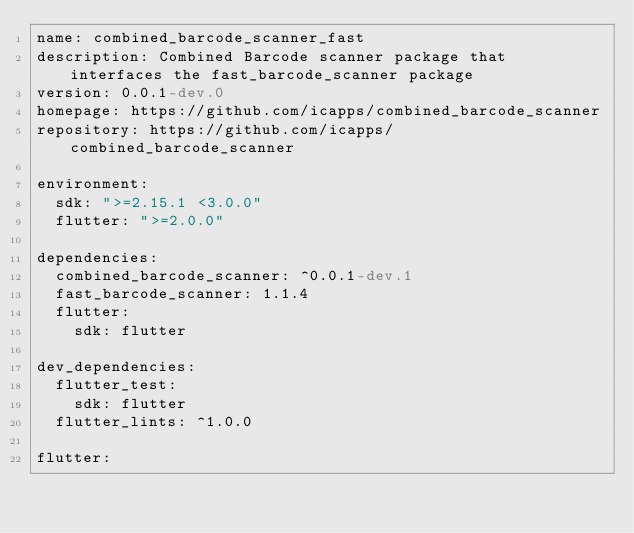Convert code to text. <code><loc_0><loc_0><loc_500><loc_500><_YAML_>name: combined_barcode_scanner_fast
description: Combined Barcode scanner package that interfaces the fast_barcode_scanner package
version: 0.0.1-dev.0
homepage: https://github.com/icapps/combined_barcode_scanner
repository: https://github.com/icapps/combined_barcode_scanner

environment:
  sdk: ">=2.15.1 <3.0.0"
  flutter: ">=2.0.0"

dependencies:
  combined_barcode_scanner: ^0.0.1-dev.1
  fast_barcode_scanner: 1.1.4
  flutter:
    sdk: flutter

dev_dependencies:
  flutter_test:
    sdk: flutter
  flutter_lints: ^1.0.0

flutter:
</code> 